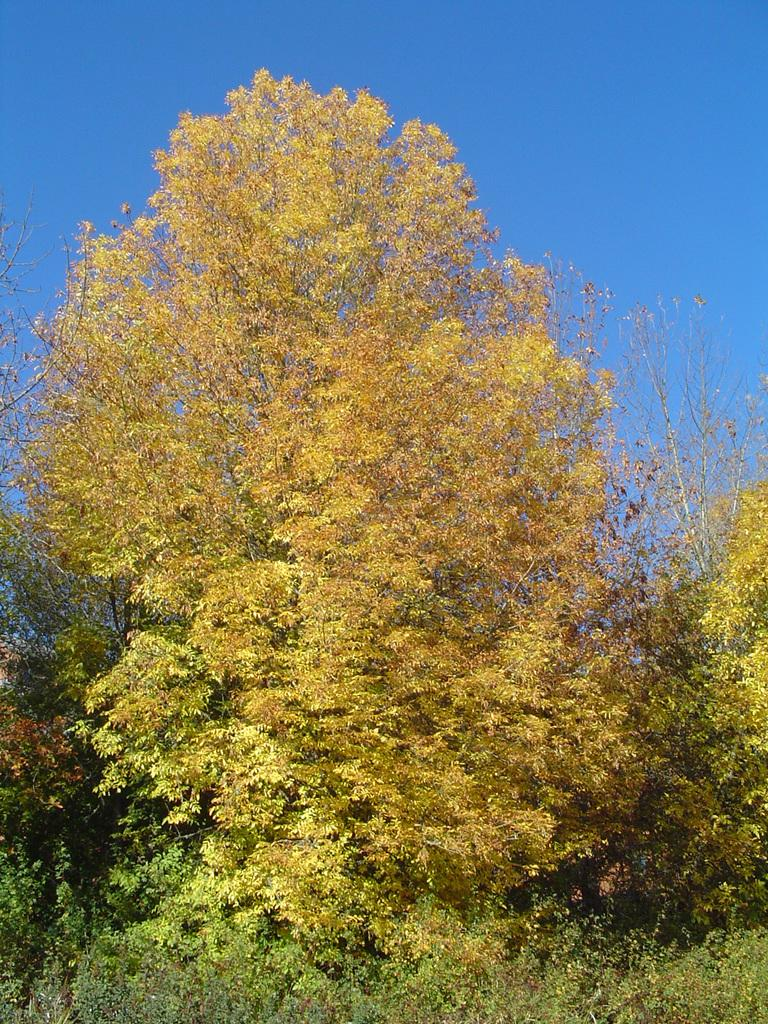What type of vegetation can be seen in the image? There are plants and trees in the image. What can be seen in the background of the image? The sky is visible in the background of the image. How many cats can be seen playing with the cows in the image? There are no cats or cows present in the image; it features plants, trees, and the sky. 